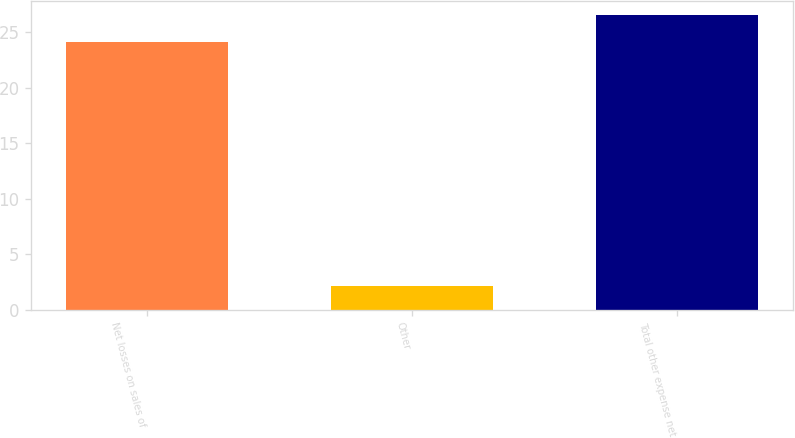Convert chart. <chart><loc_0><loc_0><loc_500><loc_500><bar_chart><fcel>Net losses on sales of<fcel>Other<fcel>Total other expense net<nl><fcel>24.1<fcel>2.1<fcel>26.51<nl></chart> 